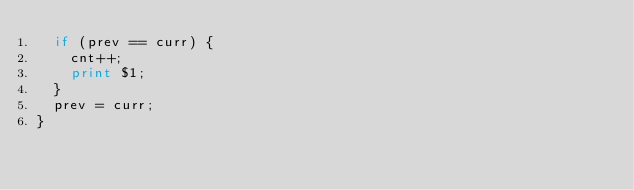Convert code to text. <code><loc_0><loc_0><loc_500><loc_500><_Awk_>  if (prev == curr) {
    cnt++;
    print $1;
  }
  prev = curr;
}</code> 